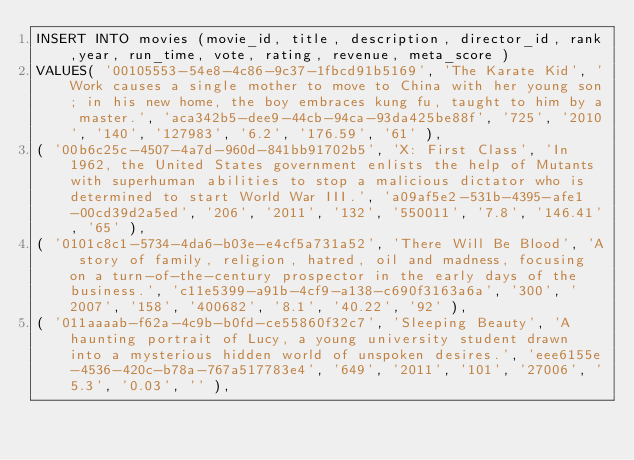<code> <loc_0><loc_0><loc_500><loc_500><_SQL_>INSERT INTO movies (movie_id, title, description, director_id, rank,year, run_time, vote, rating, revenue, meta_score )
VALUES( '00105553-54e8-4c86-9c37-1fbcd91b5169', 'The Karate Kid', 'Work causes a single mother to move to China with her young son; in his new home, the boy embraces kung fu, taught to him by a master.', 'aca342b5-dee9-44cb-94ca-93da425be88f', '725', '2010', '140', '127983', '6.2', '176.59', '61' ),
( '00b6c25c-4507-4a7d-960d-841bb91702b5', 'X: First Class', 'In 1962, the United States government enlists the help of Mutants with superhuman abilities to stop a malicious dictator who is determined to start World War III.', 'a09af5e2-531b-4395-afe1-00cd39d2a5ed', '206', '2011', '132', '550011', '7.8', '146.41', '65' ),
( '0101c8c1-5734-4da6-b03e-e4cf5a731a52', 'There Will Be Blood', 'A story of family, religion, hatred, oil and madness, focusing on a turn-of-the-century prospector in the early days of the business.', 'c11e5399-a91b-4cf9-a138-c690f3163a6a', '300', '2007', '158', '400682', '8.1', '40.22', '92' ),
( '011aaaab-f62a-4c9b-b0fd-ce55860f32c7', 'Sleeping Beauty', 'A haunting portrait of Lucy, a young university student drawn into a mysterious hidden world of unspoken desires.', 'eee6155e-4536-420c-b78a-767a517783e4', '649', '2011', '101', '27006', '5.3', '0.03', '' ),</code> 